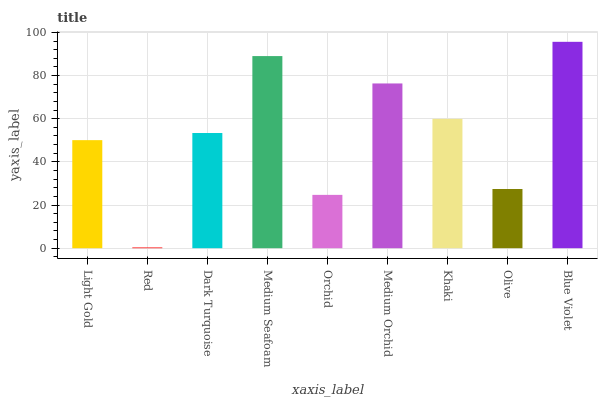Is Red the minimum?
Answer yes or no. Yes. Is Blue Violet the maximum?
Answer yes or no. Yes. Is Dark Turquoise the minimum?
Answer yes or no. No. Is Dark Turquoise the maximum?
Answer yes or no. No. Is Dark Turquoise greater than Red?
Answer yes or no. Yes. Is Red less than Dark Turquoise?
Answer yes or no. Yes. Is Red greater than Dark Turquoise?
Answer yes or no. No. Is Dark Turquoise less than Red?
Answer yes or no. No. Is Dark Turquoise the high median?
Answer yes or no. Yes. Is Dark Turquoise the low median?
Answer yes or no. Yes. Is Light Gold the high median?
Answer yes or no. No. Is Red the low median?
Answer yes or no. No. 